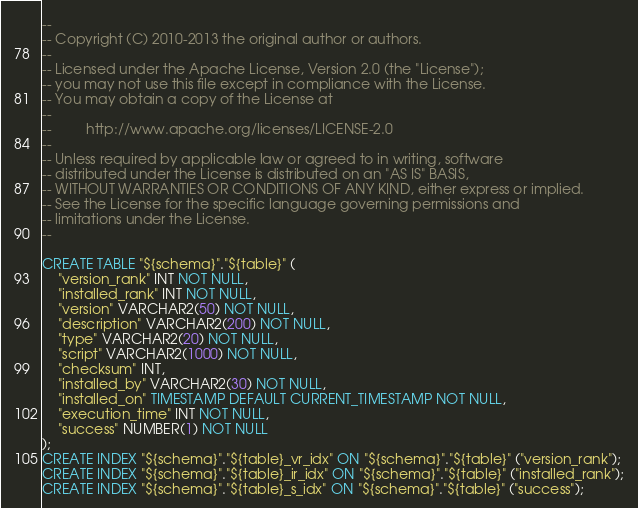<code> <loc_0><loc_0><loc_500><loc_500><_SQL_>--
-- Copyright (C) 2010-2013 the original author or authors.
--
-- Licensed under the Apache License, Version 2.0 (the "License");
-- you may not use this file except in compliance with the License.
-- You may obtain a copy of the License at
--
--         http://www.apache.org/licenses/LICENSE-2.0
--
-- Unless required by applicable law or agreed to in writing, software
-- distributed under the License is distributed on an "AS IS" BASIS,
-- WITHOUT WARRANTIES OR CONDITIONS OF ANY KIND, either express or implied.
-- See the License for the specific language governing permissions and
-- limitations under the License.
--

CREATE TABLE "${schema}"."${table}" (
    "version_rank" INT NOT NULL,
    "installed_rank" INT NOT NULL,
    "version" VARCHAR2(50) NOT NULL,
    "description" VARCHAR2(200) NOT NULL,
    "type" VARCHAR2(20) NOT NULL,
    "script" VARCHAR2(1000) NOT NULL,
    "checksum" INT,
    "installed_by" VARCHAR2(30) NOT NULL,
    "installed_on" TIMESTAMP DEFAULT CURRENT_TIMESTAMP NOT NULL,
    "execution_time" INT NOT NULL,
    "success" NUMBER(1) NOT NULL
);
CREATE INDEX "${schema}"."${table}_vr_idx" ON "${schema}"."${table}" ("version_rank");
CREATE INDEX "${schema}"."${table}_ir_idx" ON "${schema}"."${table}" ("installed_rank");
CREATE INDEX "${schema}"."${table}_s_idx" ON "${schema}"."${table}" ("success");
</code> 